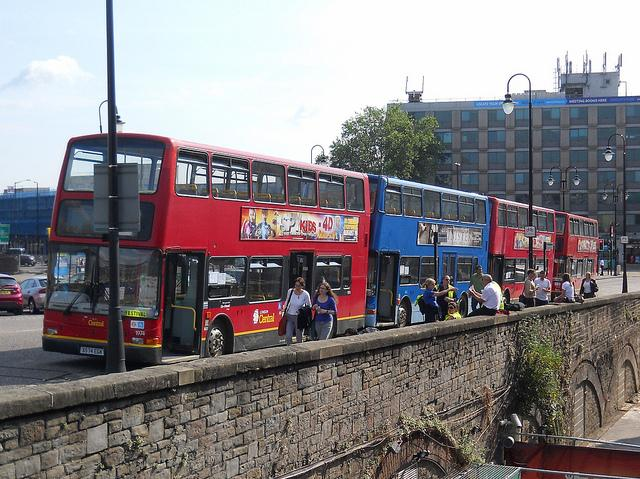Who is the queen of this territory?

Choices:
A) milena trump
B) elizabeth ii
C) lukashenko
D) ivanka trump elizabeth ii 